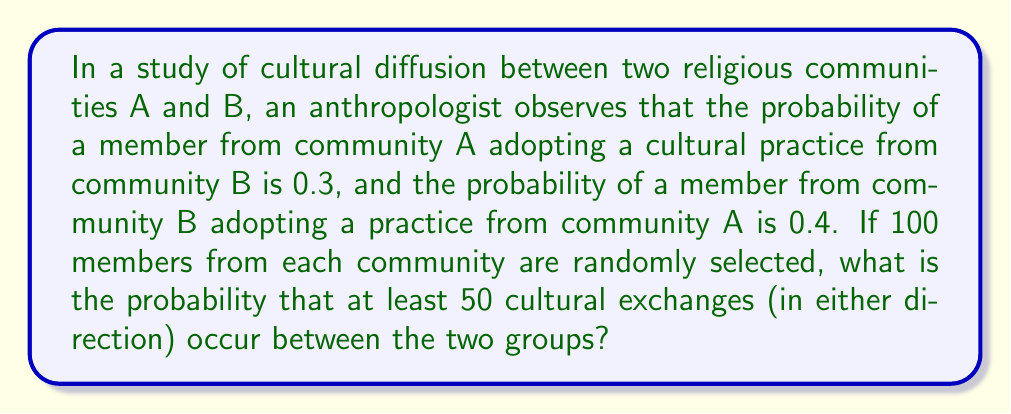Help me with this question. To solve this problem, we'll use the binomial probability distribution and the complement rule. Let's break it down step-by-step:

1) First, we need to calculate the probability of a cultural exchange occurring between any two randomly selected members:

   $P(\text{exchange}) = P(A \text{ adopts from } B) + P(B \text{ adopts from } A)$
   $P(\text{exchange}) = 0.3 + 0.4 = 0.7$

2) We have 200 possible pairs (100 from each community), and each pair has a 0.7 probability of exchange.

3) Let X be the random variable representing the number of cultural exchanges. X follows a binomial distribution with n = 200 and p = 0.7.

4) We want to find $P(X \geq 50)$. It's easier to calculate $P(X < 50)$ and then use the complement rule:

   $P(X \geq 50) = 1 - P(X < 50) = 1 - P(X \leq 49)$

5) To calculate $P(X \leq 49)$, we can use the cumulative binomial probability function:

   $$P(X \leq 49) = \sum_{k=0}^{49} \binom{200}{k} (0.7)^k (0.3)^{200-k}$$

6) This sum is computationally intensive, so we'll use the normal approximation to the binomial distribution. This is valid because np and n(1-p) are both greater than 5.

7) For a normal approximation, we need the mean and standard deviation:

   $\mu = np = 200 * 0.7 = 140$
   $\sigma = \sqrt{np(1-p)} = \sqrt{200 * 0.7 * 0.3} = \sqrt{42} \approx 6.48$

8) We need to apply a continuity correction, so we'll use 49.5 instead of 49:

   $z = \frac{49.5 - 140}{6.48} \approx -13.97$

9) Using a standard normal table or calculator, we find:

   $P(Z < -13.97) \approx 0$

10) Therefore, $P(X \geq 50) = 1 - P(X < 50) \approx 1 - 0 = 1$
Answer: The probability that at least 50 cultural exchanges occur between the two groups is approximately 1 or 100%. 